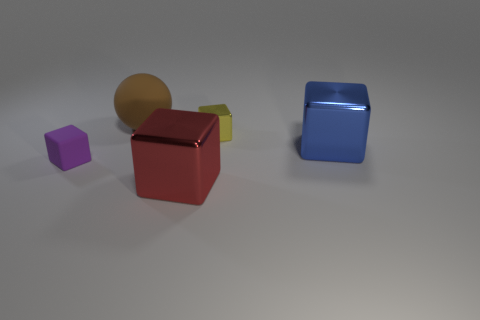Can you describe the colors of the objects in the image? Certainly! In the image, there are objects with several distinct colors: one object is red, another is blue, there's also a purple object, a yellow one, and a golden object, all with a smooth and reflective surface. 